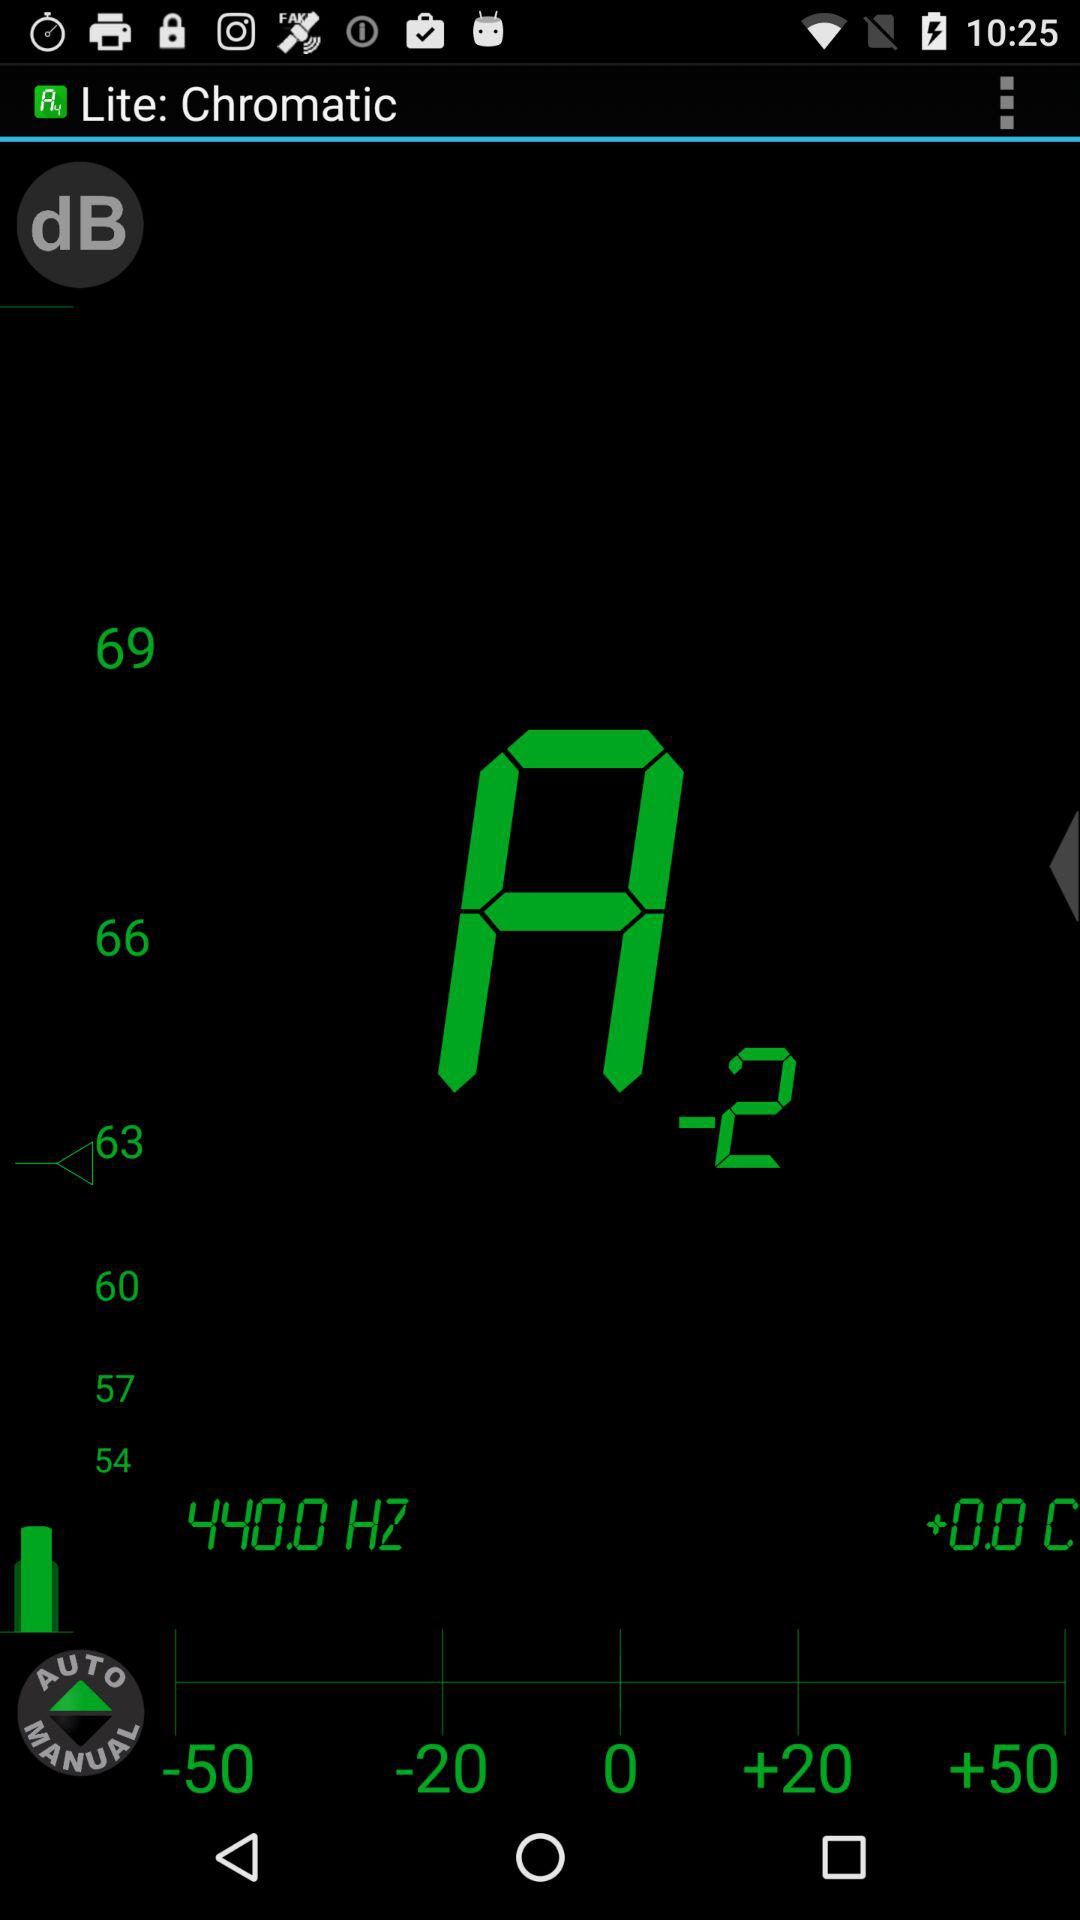What is the frequency? The frequency is 440.0 Hz. 